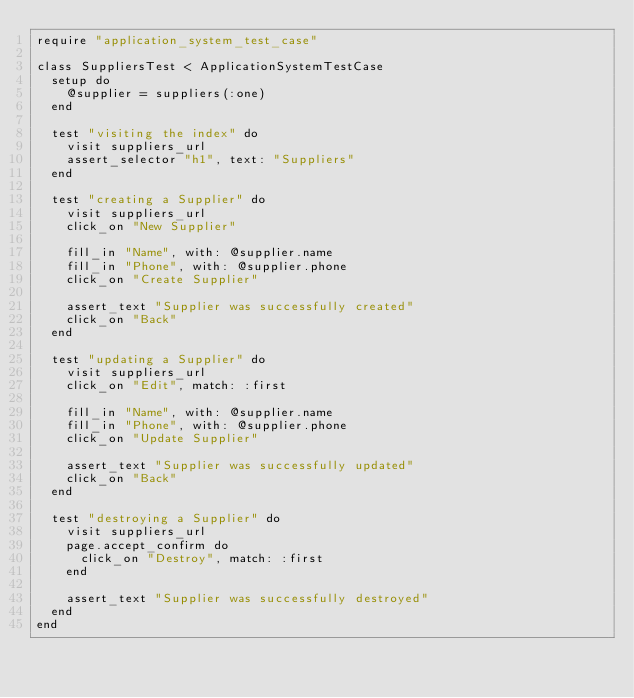<code> <loc_0><loc_0><loc_500><loc_500><_Ruby_>require "application_system_test_case"

class SuppliersTest < ApplicationSystemTestCase
  setup do
    @supplier = suppliers(:one)
  end

  test "visiting the index" do
    visit suppliers_url
    assert_selector "h1", text: "Suppliers"
  end

  test "creating a Supplier" do
    visit suppliers_url
    click_on "New Supplier"

    fill_in "Name", with: @supplier.name
    fill_in "Phone", with: @supplier.phone
    click_on "Create Supplier"

    assert_text "Supplier was successfully created"
    click_on "Back"
  end

  test "updating a Supplier" do
    visit suppliers_url
    click_on "Edit", match: :first

    fill_in "Name", with: @supplier.name
    fill_in "Phone", with: @supplier.phone
    click_on "Update Supplier"

    assert_text "Supplier was successfully updated"
    click_on "Back"
  end

  test "destroying a Supplier" do
    visit suppliers_url
    page.accept_confirm do
      click_on "Destroy", match: :first
    end

    assert_text "Supplier was successfully destroyed"
  end
end
</code> 